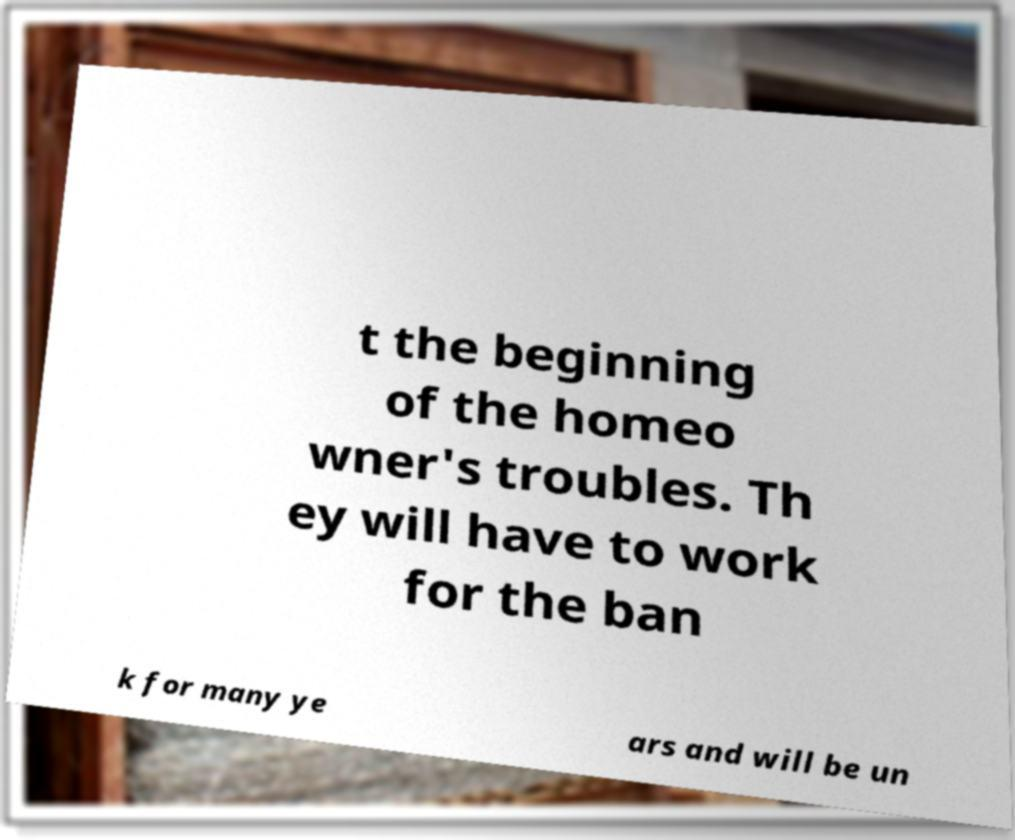I need the written content from this picture converted into text. Can you do that? t the beginning of the homeo wner's troubles. Th ey will have to work for the ban k for many ye ars and will be un 